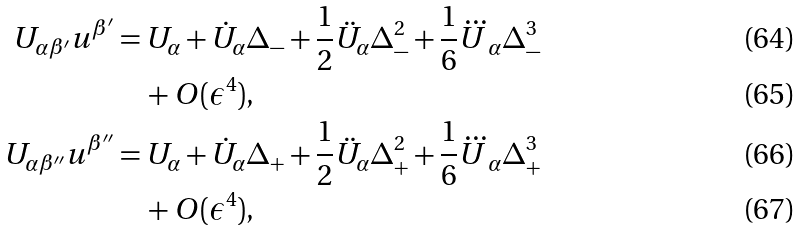Convert formula to latex. <formula><loc_0><loc_0><loc_500><loc_500>U _ { \alpha \beta ^ { \prime } } u ^ { \beta ^ { \prime } } & = U _ { \alpha } + \dot { U } _ { \alpha } \Delta _ { - } + \frac { 1 } { 2 } \ddot { U } _ { \alpha } \Delta _ { - } ^ { 2 } + \frac { 1 } { 6 } \dddot { U } _ { \alpha } \Delta _ { - } ^ { 3 } \\ & \quad + O ( \epsilon ^ { 4 } ) , \\ U _ { \alpha \beta ^ { \prime \prime } } u ^ { \beta ^ { \prime \prime } } & = U _ { \alpha } + \dot { U } _ { \alpha } \Delta _ { + } + \frac { 1 } { 2 } \ddot { U } _ { \alpha } \Delta _ { + } ^ { 2 } + \frac { 1 } { 6 } \dddot { U } _ { \alpha } \Delta _ { + } ^ { 3 } \\ & \quad + O ( \epsilon ^ { 4 } ) ,</formula> 